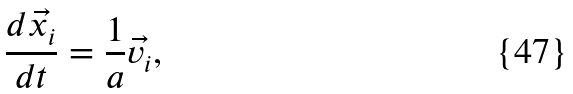Convert formula to latex. <formula><loc_0><loc_0><loc_500><loc_500>\frac { d \vec { x _ { i } } } { d t } = \frac { 1 } { a } \vec { v _ { i } } ,</formula> 